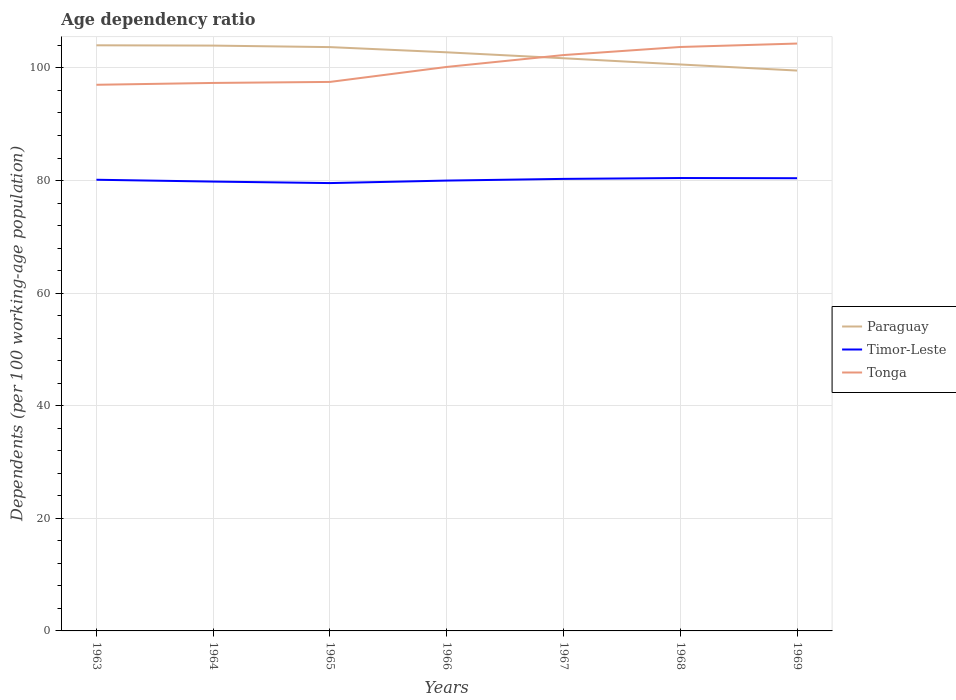How many different coloured lines are there?
Your answer should be very brief. 3. Does the line corresponding to Tonga intersect with the line corresponding to Timor-Leste?
Your answer should be very brief. No. Across all years, what is the maximum age dependency ratio in in Timor-Leste?
Offer a terse response. 79.55. In which year was the age dependency ratio in in Timor-Leste maximum?
Your answer should be compact. 1965. What is the total age dependency ratio in in Tonga in the graph?
Offer a very short reply. -6.21. What is the difference between the highest and the second highest age dependency ratio in in Paraguay?
Offer a very short reply. 4.49. Is the age dependency ratio in in Tonga strictly greater than the age dependency ratio in in Paraguay over the years?
Offer a terse response. No. How many lines are there?
Offer a terse response. 3. How many years are there in the graph?
Your answer should be compact. 7. Are the values on the major ticks of Y-axis written in scientific E-notation?
Make the answer very short. No. Does the graph contain grids?
Your response must be concise. Yes. Where does the legend appear in the graph?
Your answer should be very brief. Center right. How are the legend labels stacked?
Keep it short and to the point. Vertical. What is the title of the graph?
Ensure brevity in your answer.  Age dependency ratio. What is the label or title of the X-axis?
Ensure brevity in your answer.  Years. What is the label or title of the Y-axis?
Keep it short and to the point. Dependents (per 100 working-age population). What is the Dependents (per 100 working-age population) of Paraguay in 1963?
Your response must be concise. 104.02. What is the Dependents (per 100 working-age population) of Timor-Leste in 1963?
Provide a short and direct response. 80.14. What is the Dependents (per 100 working-age population) of Tonga in 1963?
Provide a succinct answer. 97.01. What is the Dependents (per 100 working-age population) of Paraguay in 1964?
Your answer should be very brief. 103.97. What is the Dependents (per 100 working-age population) of Timor-Leste in 1964?
Your response must be concise. 79.81. What is the Dependents (per 100 working-age population) in Tonga in 1964?
Provide a short and direct response. 97.34. What is the Dependents (per 100 working-age population) of Paraguay in 1965?
Your response must be concise. 103.7. What is the Dependents (per 100 working-age population) of Timor-Leste in 1965?
Make the answer very short. 79.55. What is the Dependents (per 100 working-age population) in Tonga in 1965?
Provide a short and direct response. 97.52. What is the Dependents (per 100 working-age population) in Paraguay in 1966?
Provide a short and direct response. 102.78. What is the Dependents (per 100 working-age population) in Timor-Leste in 1966?
Offer a terse response. 79.99. What is the Dependents (per 100 working-age population) in Tonga in 1966?
Your answer should be very brief. 100.18. What is the Dependents (per 100 working-age population) of Paraguay in 1967?
Provide a short and direct response. 101.72. What is the Dependents (per 100 working-age population) in Timor-Leste in 1967?
Offer a very short reply. 80.29. What is the Dependents (per 100 working-age population) of Tonga in 1967?
Your response must be concise. 102.29. What is the Dependents (per 100 working-age population) of Paraguay in 1968?
Your response must be concise. 100.62. What is the Dependents (per 100 working-age population) in Timor-Leste in 1968?
Give a very brief answer. 80.44. What is the Dependents (per 100 working-age population) in Tonga in 1968?
Keep it short and to the point. 103.72. What is the Dependents (per 100 working-age population) of Paraguay in 1969?
Ensure brevity in your answer.  99.53. What is the Dependents (per 100 working-age population) in Timor-Leste in 1969?
Your response must be concise. 80.41. What is the Dependents (per 100 working-age population) in Tonga in 1969?
Provide a short and direct response. 104.33. Across all years, what is the maximum Dependents (per 100 working-age population) in Paraguay?
Provide a short and direct response. 104.02. Across all years, what is the maximum Dependents (per 100 working-age population) of Timor-Leste?
Keep it short and to the point. 80.44. Across all years, what is the maximum Dependents (per 100 working-age population) of Tonga?
Give a very brief answer. 104.33. Across all years, what is the minimum Dependents (per 100 working-age population) of Paraguay?
Your answer should be compact. 99.53. Across all years, what is the minimum Dependents (per 100 working-age population) of Timor-Leste?
Ensure brevity in your answer.  79.55. Across all years, what is the minimum Dependents (per 100 working-age population) in Tonga?
Offer a very short reply. 97.01. What is the total Dependents (per 100 working-age population) of Paraguay in the graph?
Keep it short and to the point. 716.34. What is the total Dependents (per 100 working-age population) of Timor-Leste in the graph?
Provide a short and direct response. 560.64. What is the total Dependents (per 100 working-age population) of Tonga in the graph?
Your answer should be compact. 702.38. What is the difference between the Dependents (per 100 working-age population) of Paraguay in 1963 and that in 1964?
Your answer should be very brief. 0.05. What is the difference between the Dependents (per 100 working-age population) in Timor-Leste in 1963 and that in 1964?
Your answer should be compact. 0.33. What is the difference between the Dependents (per 100 working-age population) in Tonga in 1963 and that in 1964?
Make the answer very short. -0.33. What is the difference between the Dependents (per 100 working-age population) in Paraguay in 1963 and that in 1965?
Give a very brief answer. 0.32. What is the difference between the Dependents (per 100 working-age population) in Timor-Leste in 1963 and that in 1965?
Give a very brief answer. 0.59. What is the difference between the Dependents (per 100 working-age population) in Tonga in 1963 and that in 1965?
Your response must be concise. -0.51. What is the difference between the Dependents (per 100 working-age population) of Paraguay in 1963 and that in 1966?
Ensure brevity in your answer.  1.25. What is the difference between the Dependents (per 100 working-age population) in Timor-Leste in 1963 and that in 1966?
Your answer should be compact. 0.15. What is the difference between the Dependents (per 100 working-age population) of Tonga in 1963 and that in 1966?
Your answer should be very brief. -3.17. What is the difference between the Dependents (per 100 working-age population) in Paraguay in 1963 and that in 1967?
Give a very brief answer. 2.3. What is the difference between the Dependents (per 100 working-age population) in Timor-Leste in 1963 and that in 1967?
Offer a very short reply. -0.15. What is the difference between the Dependents (per 100 working-age population) in Tonga in 1963 and that in 1967?
Your answer should be compact. -5.28. What is the difference between the Dependents (per 100 working-age population) in Paraguay in 1963 and that in 1968?
Make the answer very short. 3.41. What is the difference between the Dependents (per 100 working-age population) of Timor-Leste in 1963 and that in 1968?
Give a very brief answer. -0.3. What is the difference between the Dependents (per 100 working-age population) of Tonga in 1963 and that in 1968?
Keep it short and to the point. -6.72. What is the difference between the Dependents (per 100 working-age population) in Paraguay in 1963 and that in 1969?
Make the answer very short. 4.49. What is the difference between the Dependents (per 100 working-age population) of Timor-Leste in 1963 and that in 1969?
Make the answer very short. -0.27. What is the difference between the Dependents (per 100 working-age population) of Tonga in 1963 and that in 1969?
Give a very brief answer. -7.32. What is the difference between the Dependents (per 100 working-age population) in Paraguay in 1964 and that in 1965?
Ensure brevity in your answer.  0.27. What is the difference between the Dependents (per 100 working-age population) in Timor-Leste in 1964 and that in 1965?
Your response must be concise. 0.27. What is the difference between the Dependents (per 100 working-age population) of Tonga in 1964 and that in 1965?
Provide a short and direct response. -0.18. What is the difference between the Dependents (per 100 working-age population) of Paraguay in 1964 and that in 1966?
Your answer should be compact. 1.19. What is the difference between the Dependents (per 100 working-age population) in Timor-Leste in 1964 and that in 1966?
Your answer should be compact. -0.18. What is the difference between the Dependents (per 100 working-age population) of Tonga in 1964 and that in 1966?
Provide a short and direct response. -2.84. What is the difference between the Dependents (per 100 working-age population) of Paraguay in 1964 and that in 1967?
Provide a succinct answer. 2.25. What is the difference between the Dependents (per 100 working-age population) in Timor-Leste in 1964 and that in 1967?
Your response must be concise. -0.48. What is the difference between the Dependents (per 100 working-age population) of Tonga in 1964 and that in 1967?
Offer a very short reply. -4.95. What is the difference between the Dependents (per 100 working-age population) in Paraguay in 1964 and that in 1968?
Your answer should be very brief. 3.35. What is the difference between the Dependents (per 100 working-age population) in Timor-Leste in 1964 and that in 1968?
Provide a short and direct response. -0.63. What is the difference between the Dependents (per 100 working-age population) in Tonga in 1964 and that in 1968?
Provide a short and direct response. -6.39. What is the difference between the Dependents (per 100 working-age population) of Paraguay in 1964 and that in 1969?
Offer a very short reply. 4.43. What is the difference between the Dependents (per 100 working-age population) in Timor-Leste in 1964 and that in 1969?
Provide a succinct answer. -0.6. What is the difference between the Dependents (per 100 working-age population) in Tonga in 1964 and that in 1969?
Provide a short and direct response. -7. What is the difference between the Dependents (per 100 working-age population) in Paraguay in 1965 and that in 1966?
Give a very brief answer. 0.92. What is the difference between the Dependents (per 100 working-age population) of Timor-Leste in 1965 and that in 1966?
Provide a short and direct response. -0.44. What is the difference between the Dependents (per 100 working-age population) in Tonga in 1965 and that in 1966?
Keep it short and to the point. -2.66. What is the difference between the Dependents (per 100 working-age population) in Paraguay in 1965 and that in 1967?
Offer a very short reply. 1.98. What is the difference between the Dependents (per 100 working-age population) in Timor-Leste in 1965 and that in 1967?
Give a very brief answer. -0.74. What is the difference between the Dependents (per 100 working-age population) of Tonga in 1965 and that in 1967?
Your response must be concise. -4.77. What is the difference between the Dependents (per 100 working-age population) in Paraguay in 1965 and that in 1968?
Your answer should be compact. 3.08. What is the difference between the Dependents (per 100 working-age population) of Timor-Leste in 1965 and that in 1968?
Make the answer very short. -0.9. What is the difference between the Dependents (per 100 working-age population) of Tonga in 1965 and that in 1968?
Offer a terse response. -6.21. What is the difference between the Dependents (per 100 working-age population) of Paraguay in 1965 and that in 1969?
Ensure brevity in your answer.  4.17. What is the difference between the Dependents (per 100 working-age population) of Timor-Leste in 1965 and that in 1969?
Your response must be concise. -0.86. What is the difference between the Dependents (per 100 working-age population) of Tonga in 1965 and that in 1969?
Make the answer very short. -6.82. What is the difference between the Dependents (per 100 working-age population) of Paraguay in 1966 and that in 1967?
Your answer should be compact. 1.06. What is the difference between the Dependents (per 100 working-age population) of Timor-Leste in 1966 and that in 1967?
Offer a very short reply. -0.3. What is the difference between the Dependents (per 100 working-age population) of Tonga in 1966 and that in 1967?
Offer a very short reply. -2.11. What is the difference between the Dependents (per 100 working-age population) in Paraguay in 1966 and that in 1968?
Your answer should be very brief. 2.16. What is the difference between the Dependents (per 100 working-age population) of Timor-Leste in 1966 and that in 1968?
Make the answer very short. -0.45. What is the difference between the Dependents (per 100 working-age population) of Tonga in 1966 and that in 1968?
Ensure brevity in your answer.  -3.54. What is the difference between the Dependents (per 100 working-age population) in Paraguay in 1966 and that in 1969?
Keep it short and to the point. 3.24. What is the difference between the Dependents (per 100 working-age population) in Timor-Leste in 1966 and that in 1969?
Keep it short and to the point. -0.42. What is the difference between the Dependents (per 100 working-age population) of Tonga in 1966 and that in 1969?
Make the answer very short. -4.15. What is the difference between the Dependents (per 100 working-age population) of Paraguay in 1967 and that in 1968?
Make the answer very short. 1.1. What is the difference between the Dependents (per 100 working-age population) of Timor-Leste in 1967 and that in 1968?
Keep it short and to the point. -0.15. What is the difference between the Dependents (per 100 working-age population) in Tonga in 1967 and that in 1968?
Offer a terse response. -1.44. What is the difference between the Dependents (per 100 working-age population) of Paraguay in 1967 and that in 1969?
Make the answer very short. 2.19. What is the difference between the Dependents (per 100 working-age population) of Timor-Leste in 1967 and that in 1969?
Offer a very short reply. -0.12. What is the difference between the Dependents (per 100 working-age population) of Tonga in 1967 and that in 1969?
Ensure brevity in your answer.  -2.04. What is the difference between the Dependents (per 100 working-age population) of Paraguay in 1968 and that in 1969?
Make the answer very short. 1.08. What is the difference between the Dependents (per 100 working-age population) in Timor-Leste in 1968 and that in 1969?
Keep it short and to the point. 0.03. What is the difference between the Dependents (per 100 working-age population) of Tonga in 1968 and that in 1969?
Your response must be concise. -0.61. What is the difference between the Dependents (per 100 working-age population) of Paraguay in 1963 and the Dependents (per 100 working-age population) of Timor-Leste in 1964?
Keep it short and to the point. 24.21. What is the difference between the Dependents (per 100 working-age population) in Paraguay in 1963 and the Dependents (per 100 working-age population) in Tonga in 1964?
Make the answer very short. 6.69. What is the difference between the Dependents (per 100 working-age population) of Timor-Leste in 1963 and the Dependents (per 100 working-age population) of Tonga in 1964?
Make the answer very short. -17.2. What is the difference between the Dependents (per 100 working-age population) of Paraguay in 1963 and the Dependents (per 100 working-age population) of Timor-Leste in 1965?
Your answer should be compact. 24.47. What is the difference between the Dependents (per 100 working-age population) of Paraguay in 1963 and the Dependents (per 100 working-age population) of Tonga in 1965?
Provide a succinct answer. 6.51. What is the difference between the Dependents (per 100 working-age population) of Timor-Leste in 1963 and the Dependents (per 100 working-age population) of Tonga in 1965?
Offer a very short reply. -17.38. What is the difference between the Dependents (per 100 working-age population) in Paraguay in 1963 and the Dependents (per 100 working-age population) in Timor-Leste in 1966?
Provide a short and direct response. 24.03. What is the difference between the Dependents (per 100 working-age population) in Paraguay in 1963 and the Dependents (per 100 working-age population) in Tonga in 1966?
Your answer should be very brief. 3.84. What is the difference between the Dependents (per 100 working-age population) of Timor-Leste in 1963 and the Dependents (per 100 working-age population) of Tonga in 1966?
Your answer should be very brief. -20.04. What is the difference between the Dependents (per 100 working-age population) of Paraguay in 1963 and the Dependents (per 100 working-age population) of Timor-Leste in 1967?
Your answer should be very brief. 23.73. What is the difference between the Dependents (per 100 working-age population) in Paraguay in 1963 and the Dependents (per 100 working-age population) in Tonga in 1967?
Provide a short and direct response. 1.73. What is the difference between the Dependents (per 100 working-age population) in Timor-Leste in 1963 and the Dependents (per 100 working-age population) in Tonga in 1967?
Offer a terse response. -22.15. What is the difference between the Dependents (per 100 working-age population) in Paraguay in 1963 and the Dependents (per 100 working-age population) in Timor-Leste in 1968?
Provide a short and direct response. 23.58. What is the difference between the Dependents (per 100 working-age population) of Paraguay in 1963 and the Dependents (per 100 working-age population) of Tonga in 1968?
Your answer should be compact. 0.3. What is the difference between the Dependents (per 100 working-age population) in Timor-Leste in 1963 and the Dependents (per 100 working-age population) in Tonga in 1968?
Make the answer very short. -23.58. What is the difference between the Dependents (per 100 working-age population) in Paraguay in 1963 and the Dependents (per 100 working-age population) in Timor-Leste in 1969?
Your response must be concise. 23.61. What is the difference between the Dependents (per 100 working-age population) in Paraguay in 1963 and the Dependents (per 100 working-age population) in Tonga in 1969?
Offer a terse response. -0.31. What is the difference between the Dependents (per 100 working-age population) in Timor-Leste in 1963 and the Dependents (per 100 working-age population) in Tonga in 1969?
Provide a succinct answer. -24.19. What is the difference between the Dependents (per 100 working-age population) of Paraguay in 1964 and the Dependents (per 100 working-age population) of Timor-Leste in 1965?
Offer a terse response. 24.42. What is the difference between the Dependents (per 100 working-age population) in Paraguay in 1964 and the Dependents (per 100 working-age population) in Tonga in 1965?
Keep it short and to the point. 6.45. What is the difference between the Dependents (per 100 working-age population) in Timor-Leste in 1964 and the Dependents (per 100 working-age population) in Tonga in 1965?
Your answer should be compact. -17.7. What is the difference between the Dependents (per 100 working-age population) of Paraguay in 1964 and the Dependents (per 100 working-age population) of Timor-Leste in 1966?
Provide a succinct answer. 23.98. What is the difference between the Dependents (per 100 working-age population) in Paraguay in 1964 and the Dependents (per 100 working-age population) in Tonga in 1966?
Offer a terse response. 3.79. What is the difference between the Dependents (per 100 working-age population) of Timor-Leste in 1964 and the Dependents (per 100 working-age population) of Tonga in 1966?
Ensure brevity in your answer.  -20.37. What is the difference between the Dependents (per 100 working-age population) in Paraguay in 1964 and the Dependents (per 100 working-age population) in Timor-Leste in 1967?
Keep it short and to the point. 23.68. What is the difference between the Dependents (per 100 working-age population) of Paraguay in 1964 and the Dependents (per 100 working-age population) of Tonga in 1967?
Your answer should be compact. 1.68. What is the difference between the Dependents (per 100 working-age population) in Timor-Leste in 1964 and the Dependents (per 100 working-age population) in Tonga in 1967?
Ensure brevity in your answer.  -22.47. What is the difference between the Dependents (per 100 working-age population) of Paraguay in 1964 and the Dependents (per 100 working-age population) of Timor-Leste in 1968?
Provide a succinct answer. 23.53. What is the difference between the Dependents (per 100 working-age population) in Paraguay in 1964 and the Dependents (per 100 working-age population) in Tonga in 1968?
Give a very brief answer. 0.25. What is the difference between the Dependents (per 100 working-age population) in Timor-Leste in 1964 and the Dependents (per 100 working-age population) in Tonga in 1968?
Keep it short and to the point. -23.91. What is the difference between the Dependents (per 100 working-age population) in Paraguay in 1964 and the Dependents (per 100 working-age population) in Timor-Leste in 1969?
Your answer should be compact. 23.56. What is the difference between the Dependents (per 100 working-age population) of Paraguay in 1964 and the Dependents (per 100 working-age population) of Tonga in 1969?
Ensure brevity in your answer.  -0.36. What is the difference between the Dependents (per 100 working-age population) in Timor-Leste in 1964 and the Dependents (per 100 working-age population) in Tonga in 1969?
Offer a very short reply. -24.52. What is the difference between the Dependents (per 100 working-age population) of Paraguay in 1965 and the Dependents (per 100 working-age population) of Timor-Leste in 1966?
Give a very brief answer. 23.71. What is the difference between the Dependents (per 100 working-age population) in Paraguay in 1965 and the Dependents (per 100 working-age population) in Tonga in 1966?
Ensure brevity in your answer.  3.52. What is the difference between the Dependents (per 100 working-age population) in Timor-Leste in 1965 and the Dependents (per 100 working-age population) in Tonga in 1966?
Ensure brevity in your answer.  -20.63. What is the difference between the Dependents (per 100 working-age population) in Paraguay in 1965 and the Dependents (per 100 working-age population) in Timor-Leste in 1967?
Give a very brief answer. 23.41. What is the difference between the Dependents (per 100 working-age population) of Paraguay in 1965 and the Dependents (per 100 working-age population) of Tonga in 1967?
Your answer should be very brief. 1.41. What is the difference between the Dependents (per 100 working-age population) in Timor-Leste in 1965 and the Dependents (per 100 working-age population) in Tonga in 1967?
Your answer should be compact. -22.74. What is the difference between the Dependents (per 100 working-age population) of Paraguay in 1965 and the Dependents (per 100 working-age population) of Timor-Leste in 1968?
Your response must be concise. 23.26. What is the difference between the Dependents (per 100 working-age population) in Paraguay in 1965 and the Dependents (per 100 working-age population) in Tonga in 1968?
Your response must be concise. -0.02. What is the difference between the Dependents (per 100 working-age population) in Timor-Leste in 1965 and the Dependents (per 100 working-age population) in Tonga in 1968?
Keep it short and to the point. -24.17. What is the difference between the Dependents (per 100 working-age population) of Paraguay in 1965 and the Dependents (per 100 working-age population) of Timor-Leste in 1969?
Your answer should be compact. 23.29. What is the difference between the Dependents (per 100 working-age population) in Paraguay in 1965 and the Dependents (per 100 working-age population) in Tonga in 1969?
Ensure brevity in your answer.  -0.63. What is the difference between the Dependents (per 100 working-age population) of Timor-Leste in 1965 and the Dependents (per 100 working-age population) of Tonga in 1969?
Offer a terse response. -24.78. What is the difference between the Dependents (per 100 working-age population) of Paraguay in 1966 and the Dependents (per 100 working-age population) of Timor-Leste in 1967?
Your response must be concise. 22.48. What is the difference between the Dependents (per 100 working-age population) in Paraguay in 1966 and the Dependents (per 100 working-age population) in Tonga in 1967?
Your response must be concise. 0.49. What is the difference between the Dependents (per 100 working-age population) in Timor-Leste in 1966 and the Dependents (per 100 working-age population) in Tonga in 1967?
Offer a terse response. -22.3. What is the difference between the Dependents (per 100 working-age population) in Paraguay in 1966 and the Dependents (per 100 working-age population) in Timor-Leste in 1968?
Provide a short and direct response. 22.33. What is the difference between the Dependents (per 100 working-age population) in Paraguay in 1966 and the Dependents (per 100 working-age population) in Tonga in 1968?
Offer a terse response. -0.95. What is the difference between the Dependents (per 100 working-age population) of Timor-Leste in 1966 and the Dependents (per 100 working-age population) of Tonga in 1968?
Your answer should be very brief. -23.73. What is the difference between the Dependents (per 100 working-age population) of Paraguay in 1966 and the Dependents (per 100 working-age population) of Timor-Leste in 1969?
Provide a short and direct response. 22.37. What is the difference between the Dependents (per 100 working-age population) of Paraguay in 1966 and the Dependents (per 100 working-age population) of Tonga in 1969?
Offer a very short reply. -1.56. What is the difference between the Dependents (per 100 working-age population) of Timor-Leste in 1966 and the Dependents (per 100 working-age population) of Tonga in 1969?
Your response must be concise. -24.34. What is the difference between the Dependents (per 100 working-age population) in Paraguay in 1967 and the Dependents (per 100 working-age population) in Timor-Leste in 1968?
Provide a succinct answer. 21.28. What is the difference between the Dependents (per 100 working-age population) in Paraguay in 1967 and the Dependents (per 100 working-age population) in Tonga in 1968?
Give a very brief answer. -2. What is the difference between the Dependents (per 100 working-age population) in Timor-Leste in 1967 and the Dependents (per 100 working-age population) in Tonga in 1968?
Ensure brevity in your answer.  -23.43. What is the difference between the Dependents (per 100 working-age population) of Paraguay in 1967 and the Dependents (per 100 working-age population) of Timor-Leste in 1969?
Offer a very short reply. 21.31. What is the difference between the Dependents (per 100 working-age population) of Paraguay in 1967 and the Dependents (per 100 working-age population) of Tonga in 1969?
Your response must be concise. -2.61. What is the difference between the Dependents (per 100 working-age population) in Timor-Leste in 1967 and the Dependents (per 100 working-age population) in Tonga in 1969?
Offer a very short reply. -24.04. What is the difference between the Dependents (per 100 working-age population) of Paraguay in 1968 and the Dependents (per 100 working-age population) of Timor-Leste in 1969?
Offer a terse response. 20.21. What is the difference between the Dependents (per 100 working-age population) in Paraguay in 1968 and the Dependents (per 100 working-age population) in Tonga in 1969?
Offer a terse response. -3.72. What is the difference between the Dependents (per 100 working-age population) of Timor-Leste in 1968 and the Dependents (per 100 working-age population) of Tonga in 1969?
Give a very brief answer. -23.89. What is the average Dependents (per 100 working-age population) of Paraguay per year?
Give a very brief answer. 102.33. What is the average Dependents (per 100 working-age population) in Timor-Leste per year?
Keep it short and to the point. 80.09. What is the average Dependents (per 100 working-age population) in Tonga per year?
Your response must be concise. 100.34. In the year 1963, what is the difference between the Dependents (per 100 working-age population) of Paraguay and Dependents (per 100 working-age population) of Timor-Leste?
Provide a succinct answer. 23.88. In the year 1963, what is the difference between the Dependents (per 100 working-age population) of Paraguay and Dependents (per 100 working-age population) of Tonga?
Your answer should be very brief. 7.01. In the year 1963, what is the difference between the Dependents (per 100 working-age population) in Timor-Leste and Dependents (per 100 working-age population) in Tonga?
Your answer should be compact. -16.87. In the year 1964, what is the difference between the Dependents (per 100 working-age population) in Paraguay and Dependents (per 100 working-age population) in Timor-Leste?
Your answer should be very brief. 24.16. In the year 1964, what is the difference between the Dependents (per 100 working-age population) in Paraguay and Dependents (per 100 working-age population) in Tonga?
Offer a very short reply. 6.63. In the year 1964, what is the difference between the Dependents (per 100 working-age population) in Timor-Leste and Dependents (per 100 working-age population) in Tonga?
Offer a terse response. -17.52. In the year 1965, what is the difference between the Dependents (per 100 working-age population) of Paraguay and Dependents (per 100 working-age population) of Timor-Leste?
Your answer should be very brief. 24.15. In the year 1965, what is the difference between the Dependents (per 100 working-age population) of Paraguay and Dependents (per 100 working-age population) of Tonga?
Keep it short and to the point. 6.18. In the year 1965, what is the difference between the Dependents (per 100 working-age population) in Timor-Leste and Dependents (per 100 working-age population) in Tonga?
Your answer should be compact. -17.97. In the year 1966, what is the difference between the Dependents (per 100 working-age population) in Paraguay and Dependents (per 100 working-age population) in Timor-Leste?
Provide a succinct answer. 22.78. In the year 1966, what is the difference between the Dependents (per 100 working-age population) in Paraguay and Dependents (per 100 working-age population) in Tonga?
Make the answer very short. 2.6. In the year 1966, what is the difference between the Dependents (per 100 working-age population) in Timor-Leste and Dependents (per 100 working-age population) in Tonga?
Offer a very short reply. -20.19. In the year 1967, what is the difference between the Dependents (per 100 working-age population) in Paraguay and Dependents (per 100 working-age population) in Timor-Leste?
Provide a succinct answer. 21.43. In the year 1967, what is the difference between the Dependents (per 100 working-age population) in Paraguay and Dependents (per 100 working-age population) in Tonga?
Your answer should be very brief. -0.57. In the year 1967, what is the difference between the Dependents (per 100 working-age population) in Timor-Leste and Dependents (per 100 working-age population) in Tonga?
Your answer should be very brief. -21.99. In the year 1968, what is the difference between the Dependents (per 100 working-age population) in Paraguay and Dependents (per 100 working-age population) in Timor-Leste?
Offer a very short reply. 20.17. In the year 1968, what is the difference between the Dependents (per 100 working-age population) in Paraguay and Dependents (per 100 working-age population) in Tonga?
Offer a very short reply. -3.11. In the year 1968, what is the difference between the Dependents (per 100 working-age population) in Timor-Leste and Dependents (per 100 working-age population) in Tonga?
Your answer should be very brief. -23.28. In the year 1969, what is the difference between the Dependents (per 100 working-age population) of Paraguay and Dependents (per 100 working-age population) of Timor-Leste?
Offer a very short reply. 19.12. In the year 1969, what is the difference between the Dependents (per 100 working-age population) in Paraguay and Dependents (per 100 working-age population) in Tonga?
Provide a succinct answer. -4.8. In the year 1969, what is the difference between the Dependents (per 100 working-age population) in Timor-Leste and Dependents (per 100 working-age population) in Tonga?
Make the answer very short. -23.92. What is the ratio of the Dependents (per 100 working-age population) of Paraguay in 1963 to that in 1965?
Offer a terse response. 1. What is the ratio of the Dependents (per 100 working-age population) of Timor-Leste in 1963 to that in 1965?
Your response must be concise. 1.01. What is the ratio of the Dependents (per 100 working-age population) of Tonga in 1963 to that in 1965?
Offer a terse response. 0.99. What is the ratio of the Dependents (per 100 working-age population) in Paraguay in 1963 to that in 1966?
Provide a short and direct response. 1.01. What is the ratio of the Dependents (per 100 working-age population) in Tonga in 1963 to that in 1966?
Offer a very short reply. 0.97. What is the ratio of the Dependents (per 100 working-age population) in Paraguay in 1963 to that in 1967?
Provide a short and direct response. 1.02. What is the ratio of the Dependents (per 100 working-age population) of Tonga in 1963 to that in 1967?
Ensure brevity in your answer.  0.95. What is the ratio of the Dependents (per 100 working-age population) of Paraguay in 1963 to that in 1968?
Your answer should be very brief. 1.03. What is the ratio of the Dependents (per 100 working-age population) of Tonga in 1963 to that in 1968?
Your answer should be very brief. 0.94. What is the ratio of the Dependents (per 100 working-age population) of Paraguay in 1963 to that in 1969?
Offer a very short reply. 1.05. What is the ratio of the Dependents (per 100 working-age population) of Tonga in 1963 to that in 1969?
Keep it short and to the point. 0.93. What is the ratio of the Dependents (per 100 working-age population) of Paraguay in 1964 to that in 1966?
Your answer should be compact. 1.01. What is the ratio of the Dependents (per 100 working-age population) in Timor-Leste in 1964 to that in 1966?
Give a very brief answer. 1. What is the ratio of the Dependents (per 100 working-age population) of Tonga in 1964 to that in 1966?
Keep it short and to the point. 0.97. What is the ratio of the Dependents (per 100 working-age population) of Paraguay in 1964 to that in 1967?
Your response must be concise. 1.02. What is the ratio of the Dependents (per 100 working-age population) of Timor-Leste in 1964 to that in 1967?
Make the answer very short. 0.99. What is the ratio of the Dependents (per 100 working-age population) in Tonga in 1964 to that in 1967?
Offer a terse response. 0.95. What is the ratio of the Dependents (per 100 working-age population) in Paraguay in 1964 to that in 1968?
Make the answer very short. 1.03. What is the ratio of the Dependents (per 100 working-age population) of Timor-Leste in 1964 to that in 1968?
Offer a terse response. 0.99. What is the ratio of the Dependents (per 100 working-age population) of Tonga in 1964 to that in 1968?
Your answer should be compact. 0.94. What is the ratio of the Dependents (per 100 working-age population) in Paraguay in 1964 to that in 1969?
Your response must be concise. 1.04. What is the ratio of the Dependents (per 100 working-age population) in Tonga in 1964 to that in 1969?
Your response must be concise. 0.93. What is the ratio of the Dependents (per 100 working-age population) in Paraguay in 1965 to that in 1966?
Keep it short and to the point. 1.01. What is the ratio of the Dependents (per 100 working-age population) of Timor-Leste in 1965 to that in 1966?
Ensure brevity in your answer.  0.99. What is the ratio of the Dependents (per 100 working-age population) of Tonga in 1965 to that in 1966?
Provide a short and direct response. 0.97. What is the ratio of the Dependents (per 100 working-age population) in Paraguay in 1965 to that in 1967?
Keep it short and to the point. 1.02. What is the ratio of the Dependents (per 100 working-age population) in Tonga in 1965 to that in 1967?
Your answer should be compact. 0.95. What is the ratio of the Dependents (per 100 working-age population) of Paraguay in 1965 to that in 1968?
Provide a short and direct response. 1.03. What is the ratio of the Dependents (per 100 working-age population) of Timor-Leste in 1965 to that in 1968?
Keep it short and to the point. 0.99. What is the ratio of the Dependents (per 100 working-age population) in Tonga in 1965 to that in 1968?
Provide a short and direct response. 0.94. What is the ratio of the Dependents (per 100 working-age population) in Paraguay in 1965 to that in 1969?
Your answer should be compact. 1.04. What is the ratio of the Dependents (per 100 working-age population) in Timor-Leste in 1965 to that in 1969?
Keep it short and to the point. 0.99. What is the ratio of the Dependents (per 100 working-age population) in Tonga in 1965 to that in 1969?
Keep it short and to the point. 0.93. What is the ratio of the Dependents (per 100 working-age population) in Paraguay in 1966 to that in 1967?
Offer a terse response. 1.01. What is the ratio of the Dependents (per 100 working-age population) in Timor-Leste in 1966 to that in 1967?
Give a very brief answer. 1. What is the ratio of the Dependents (per 100 working-age population) in Tonga in 1966 to that in 1967?
Provide a short and direct response. 0.98. What is the ratio of the Dependents (per 100 working-age population) in Paraguay in 1966 to that in 1968?
Your answer should be very brief. 1.02. What is the ratio of the Dependents (per 100 working-age population) in Timor-Leste in 1966 to that in 1968?
Give a very brief answer. 0.99. What is the ratio of the Dependents (per 100 working-age population) in Tonga in 1966 to that in 1968?
Your response must be concise. 0.97. What is the ratio of the Dependents (per 100 working-age population) of Paraguay in 1966 to that in 1969?
Provide a short and direct response. 1.03. What is the ratio of the Dependents (per 100 working-age population) in Timor-Leste in 1966 to that in 1969?
Offer a very short reply. 0.99. What is the ratio of the Dependents (per 100 working-age population) in Tonga in 1966 to that in 1969?
Give a very brief answer. 0.96. What is the ratio of the Dependents (per 100 working-age population) in Paraguay in 1967 to that in 1968?
Keep it short and to the point. 1.01. What is the ratio of the Dependents (per 100 working-age population) of Timor-Leste in 1967 to that in 1968?
Offer a very short reply. 1. What is the ratio of the Dependents (per 100 working-age population) of Tonga in 1967 to that in 1968?
Give a very brief answer. 0.99. What is the ratio of the Dependents (per 100 working-age population) in Paraguay in 1967 to that in 1969?
Your answer should be compact. 1.02. What is the ratio of the Dependents (per 100 working-age population) in Timor-Leste in 1967 to that in 1969?
Ensure brevity in your answer.  1. What is the ratio of the Dependents (per 100 working-age population) in Tonga in 1967 to that in 1969?
Ensure brevity in your answer.  0.98. What is the ratio of the Dependents (per 100 working-age population) in Paraguay in 1968 to that in 1969?
Make the answer very short. 1.01. What is the ratio of the Dependents (per 100 working-age population) in Timor-Leste in 1968 to that in 1969?
Ensure brevity in your answer.  1. What is the difference between the highest and the second highest Dependents (per 100 working-age population) in Paraguay?
Make the answer very short. 0.05. What is the difference between the highest and the second highest Dependents (per 100 working-age population) of Timor-Leste?
Give a very brief answer. 0.03. What is the difference between the highest and the second highest Dependents (per 100 working-age population) of Tonga?
Ensure brevity in your answer.  0.61. What is the difference between the highest and the lowest Dependents (per 100 working-age population) in Paraguay?
Offer a terse response. 4.49. What is the difference between the highest and the lowest Dependents (per 100 working-age population) in Timor-Leste?
Your answer should be very brief. 0.9. What is the difference between the highest and the lowest Dependents (per 100 working-age population) of Tonga?
Provide a succinct answer. 7.32. 